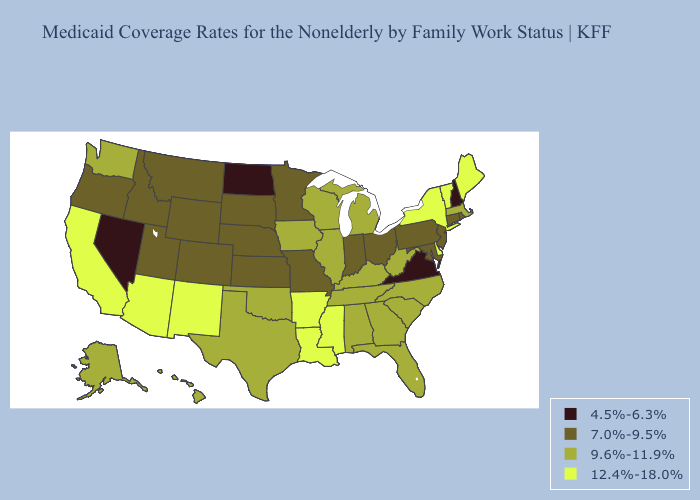Name the states that have a value in the range 12.4%-18.0%?
Short answer required. Arizona, Arkansas, California, Delaware, Louisiana, Maine, Mississippi, New Mexico, New York, Vermont. Which states hav the highest value in the Northeast?
Write a very short answer. Maine, New York, Vermont. What is the highest value in states that border Washington?
Be succinct. 7.0%-9.5%. Does Idaho have the same value as Louisiana?
Short answer required. No. Does Kansas have a higher value than Ohio?
Answer briefly. No. Does Vermont have a higher value than Louisiana?
Keep it brief. No. What is the value of Louisiana?
Keep it brief. 12.4%-18.0%. Does Connecticut have a higher value than Florida?
Concise answer only. No. What is the value of California?
Be succinct. 12.4%-18.0%. What is the lowest value in the South?
Short answer required. 4.5%-6.3%. Among the states that border New Jersey , does Pennsylvania have the highest value?
Be succinct. No. Does New York have the highest value in the USA?
Concise answer only. Yes. Does Hawaii have a lower value than Indiana?
Write a very short answer. No. What is the value of Louisiana?
Concise answer only. 12.4%-18.0%. Does Nevada have the lowest value in the USA?
Short answer required. Yes. 